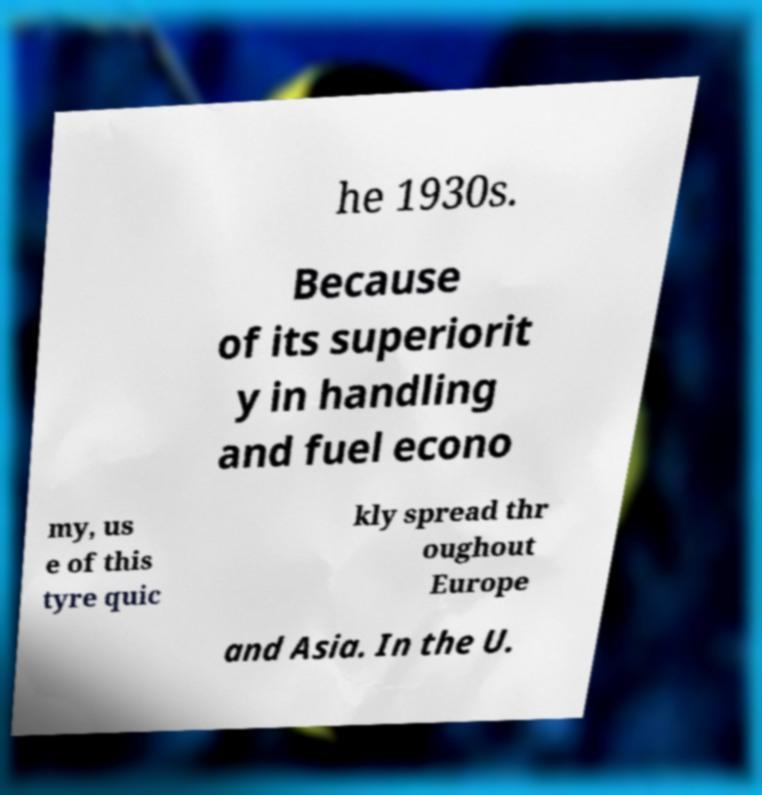I need the written content from this picture converted into text. Can you do that? he 1930s. Because of its superiorit y in handling and fuel econo my, us e of this tyre quic kly spread thr oughout Europe and Asia. In the U. 